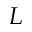Convert formula to latex. <formula><loc_0><loc_0><loc_500><loc_500>L</formula> 